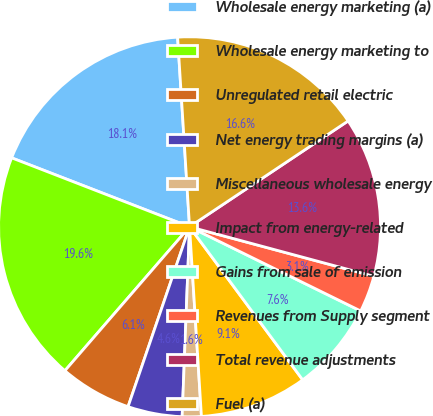Convert chart to OTSL. <chart><loc_0><loc_0><loc_500><loc_500><pie_chart><fcel>Wholesale energy marketing (a)<fcel>Wholesale energy marketing to<fcel>Unregulated retail electric<fcel>Net energy trading margins (a)<fcel>Miscellaneous wholesale energy<fcel>Impact from energy-related<fcel>Gains from sale of emission<fcel>Revenues from Supply segment<fcel>Total revenue adjustments<fcel>Fuel (a)<nl><fcel>18.09%<fcel>19.59%<fcel>6.1%<fcel>4.6%<fcel>1.61%<fcel>9.1%<fcel>7.6%<fcel>3.11%<fcel>13.6%<fcel>16.59%<nl></chart> 